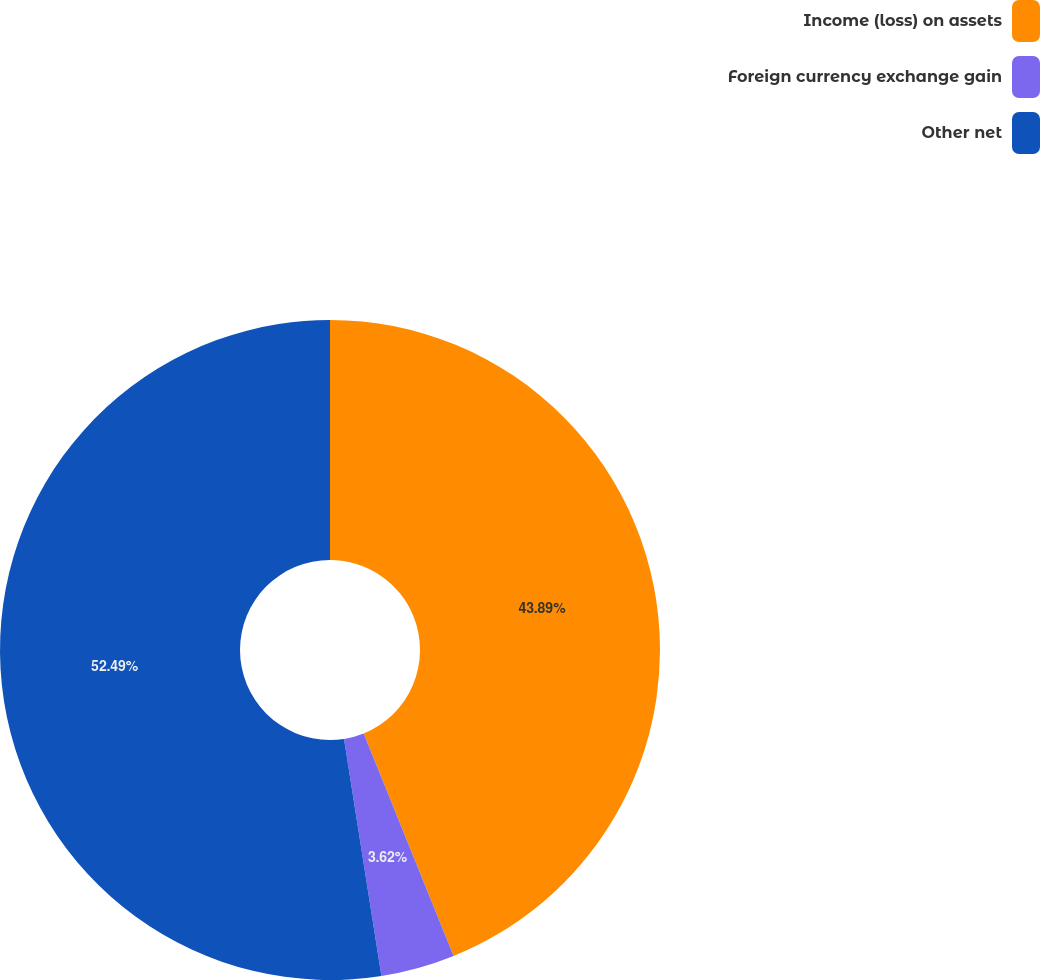<chart> <loc_0><loc_0><loc_500><loc_500><pie_chart><fcel>Income (loss) on assets<fcel>Foreign currency exchange gain<fcel>Other net<nl><fcel>43.89%<fcel>3.62%<fcel>52.49%<nl></chart> 